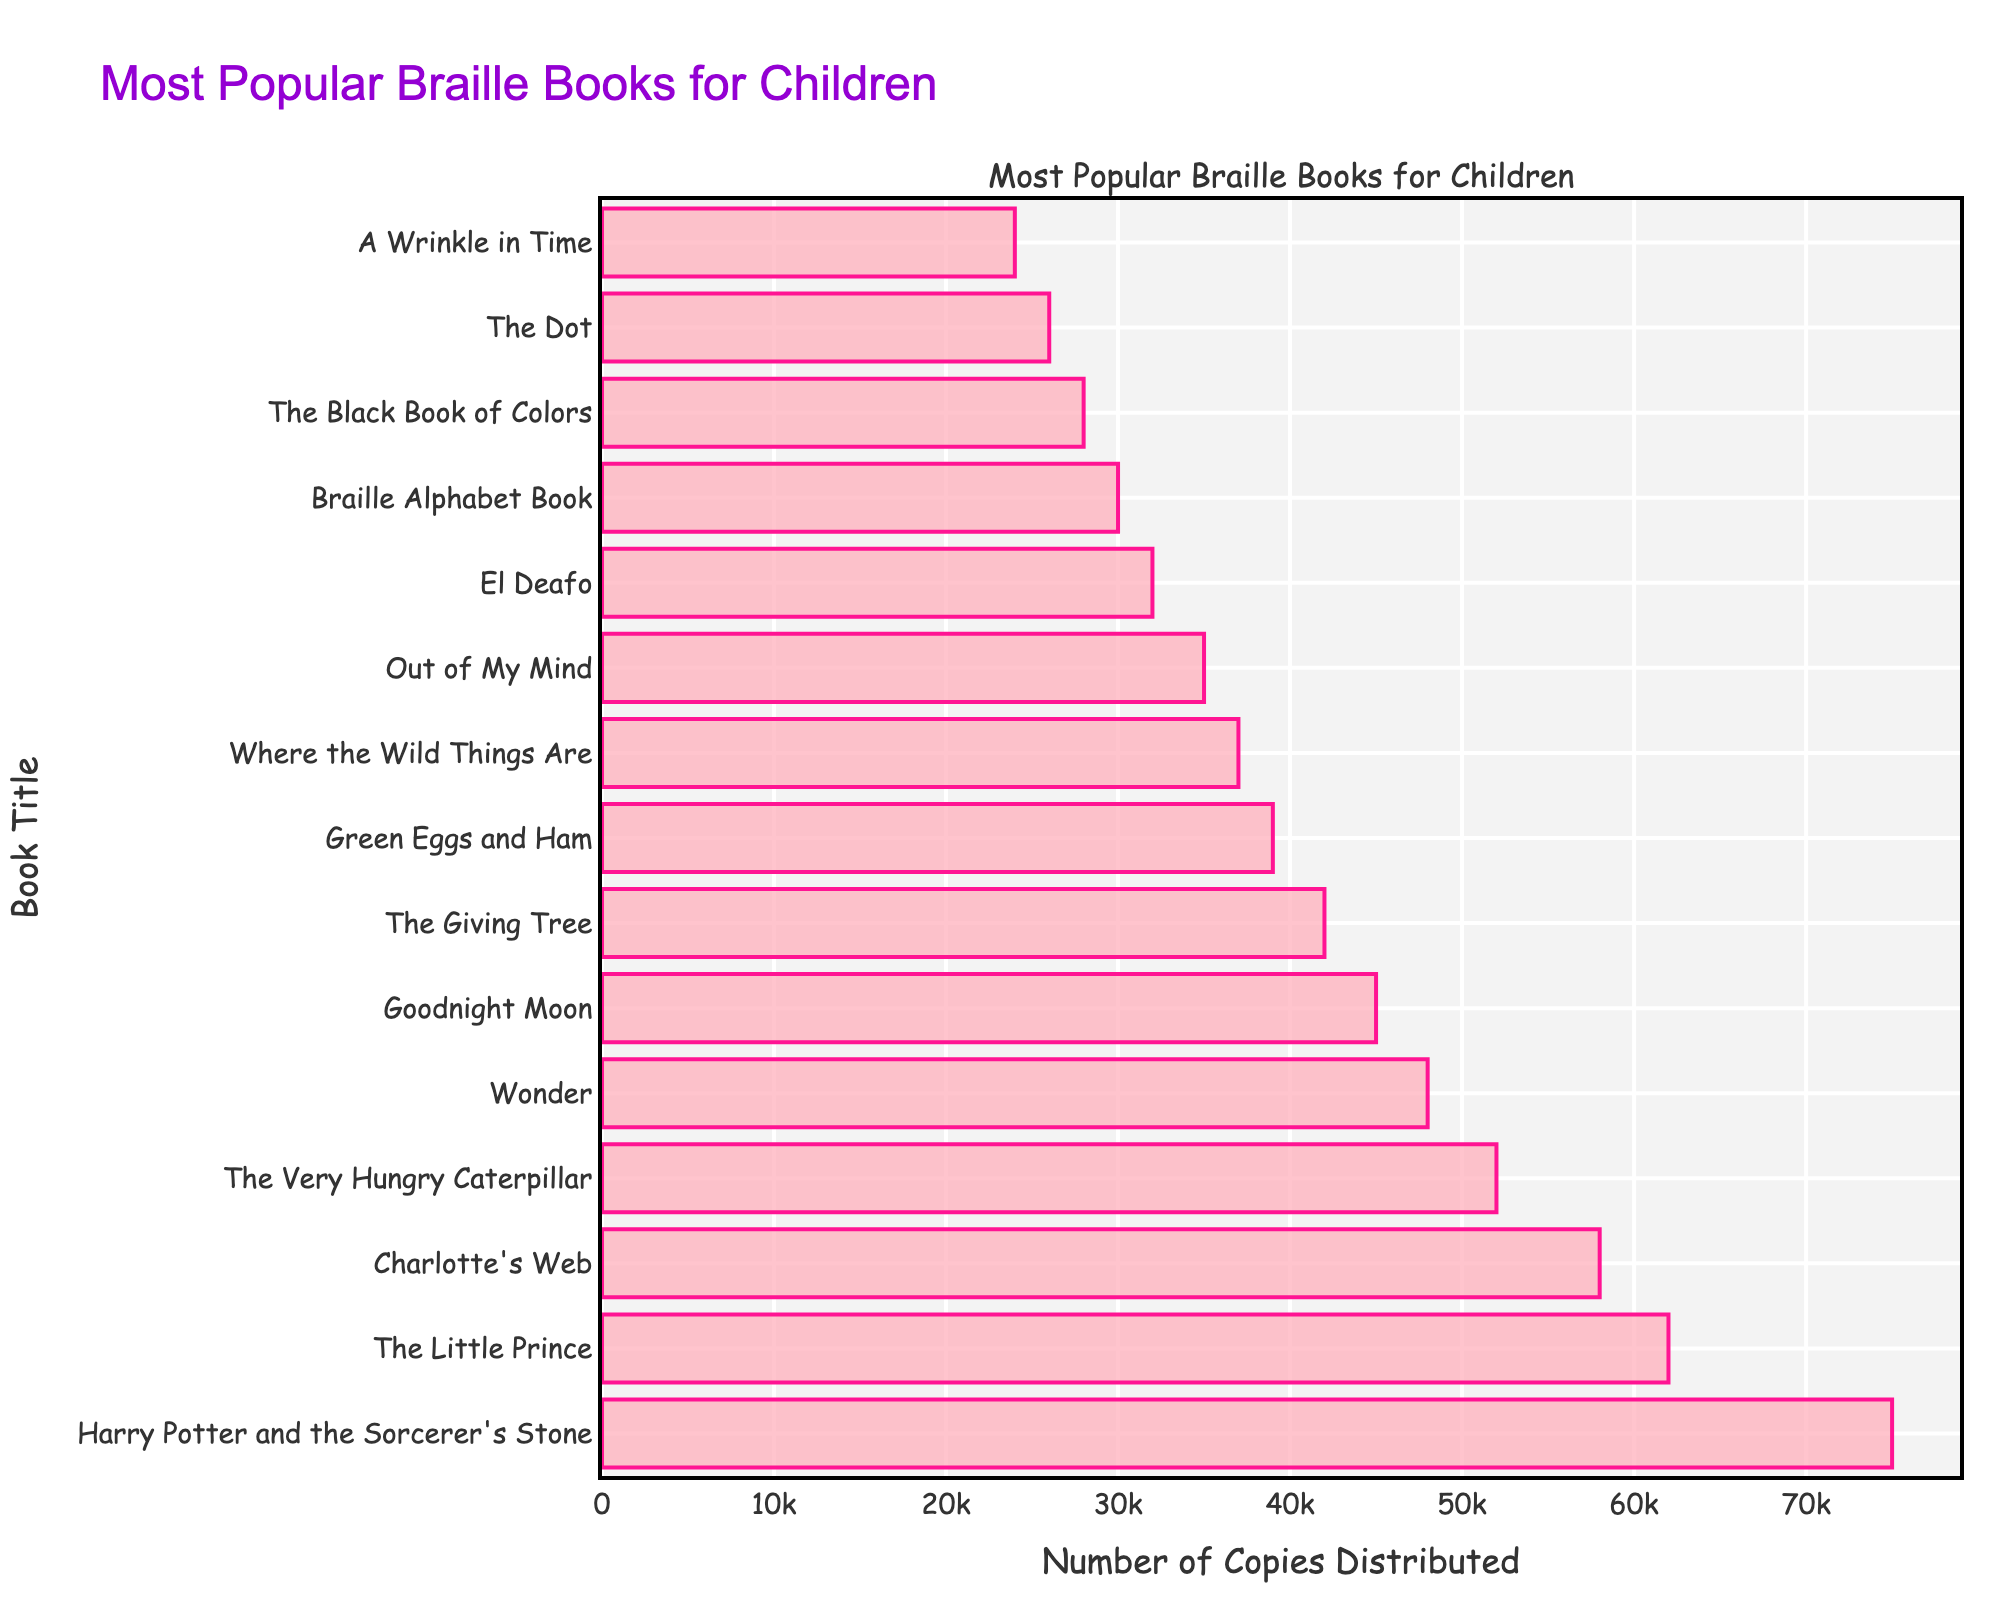What's the most popular Braille book for children? Look at the bar chart and find the bar with the greatest length. "Harry Potter and the Sorcerer's Stone" has the longest bar, indicating it has the highest number of copies distributed at 75,000.
Answer: "Harry Potter and the Sorcerer's Stone" Which Braille book has the least number of copies distributed? Locate the shortest bar in the chart. "A Wrinkle in Time" has the shortest bar, indicating it has the lowest number of copies distributed at 24,000.
Answer: "A Wrinkle in Time" How many more copies of "Harry Potter and the Sorcerer's Stone" were distributed compared to "Green Eggs and Ham"? Find the number of copies for both books and subtract the smaller number from the larger one: 75,000 (Harry Potter) - 39,000 (Green Eggs and Ham). So the difference is 36,000.
Answer: 36,000 What is the total number of copies distributed for "The Little Prince" and "Charlotte's Web"? Add the copies distributed for each book: 62,000 ("The Little Prince") + 58,000 ("Charlotte's Web"). The total is 120,000.
Answer: 120,000 Which book has more copies distributed, "Wonder" or "Goodnight Moon"? Compare the lengths of the bars for both books. "Wonder" has 48,000 copies while "Goodnight Moon" has 45,000 copies. Therefore, "Wonder" has more copies.
Answer: "Wonder" List the books with more than 50,000 copies distributed. Look at the dataset and identify all books with copies greater than 50,000. The books are: "Harry Potter and the Sorcerer's Stone", "The Little Prince", "Charlotte's Web", and "The Very Hungry Caterpillar".
Answer: "Harry Potter and the Sorcerer's Stone", "The Little Prince", "Charlotte's Web", "The Very Hungry Caterpillar" What is the average number of copies distributed for the top 3 most popular books? Add the number of copies for the top 3 books and divide by 3: (75,000 + 62,000 + 58,000) / 3. So the average is 65,000.
Answer: 65,000 What is the color of the bars representing the book titles? Visually inspect the chart to see the color of the bars. All bars are pink in the chart.
Answer: Pink How many books have at least 30,000 but less than 40,000 copies distributed? Identify and count the books that fall in the range of 30,000 to 39,999 copies. The books are "Green Eggs and Ham", "Where the Wild Things Are", and "Out of My Mind".
Answer: 3 Which book's bar is located in the middle of the chart? The middle bar corresponds to the median value in the dataset. "El Deafo", with 32,000 copies, is the middle book in the chart.
Answer: "El Deafo" 